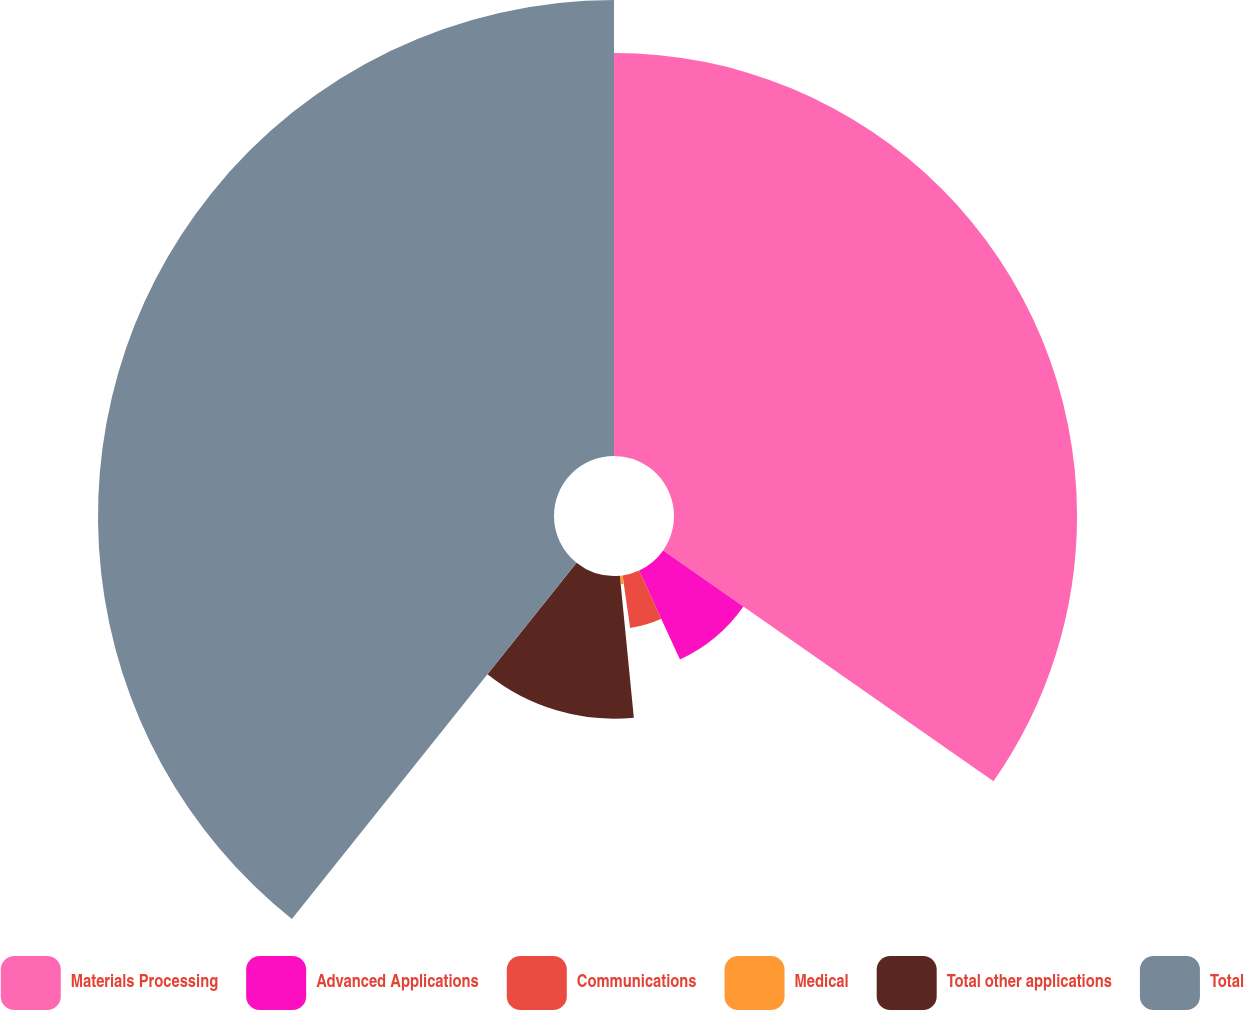Convert chart. <chart><loc_0><loc_0><loc_500><loc_500><pie_chart><fcel>Materials Processing<fcel>Advanced Applications<fcel>Communications<fcel>Medical<fcel>Total other applications<fcel>Total<nl><fcel>34.71%<fcel>8.43%<fcel>4.58%<fcel>0.72%<fcel>12.29%<fcel>39.27%<nl></chart> 